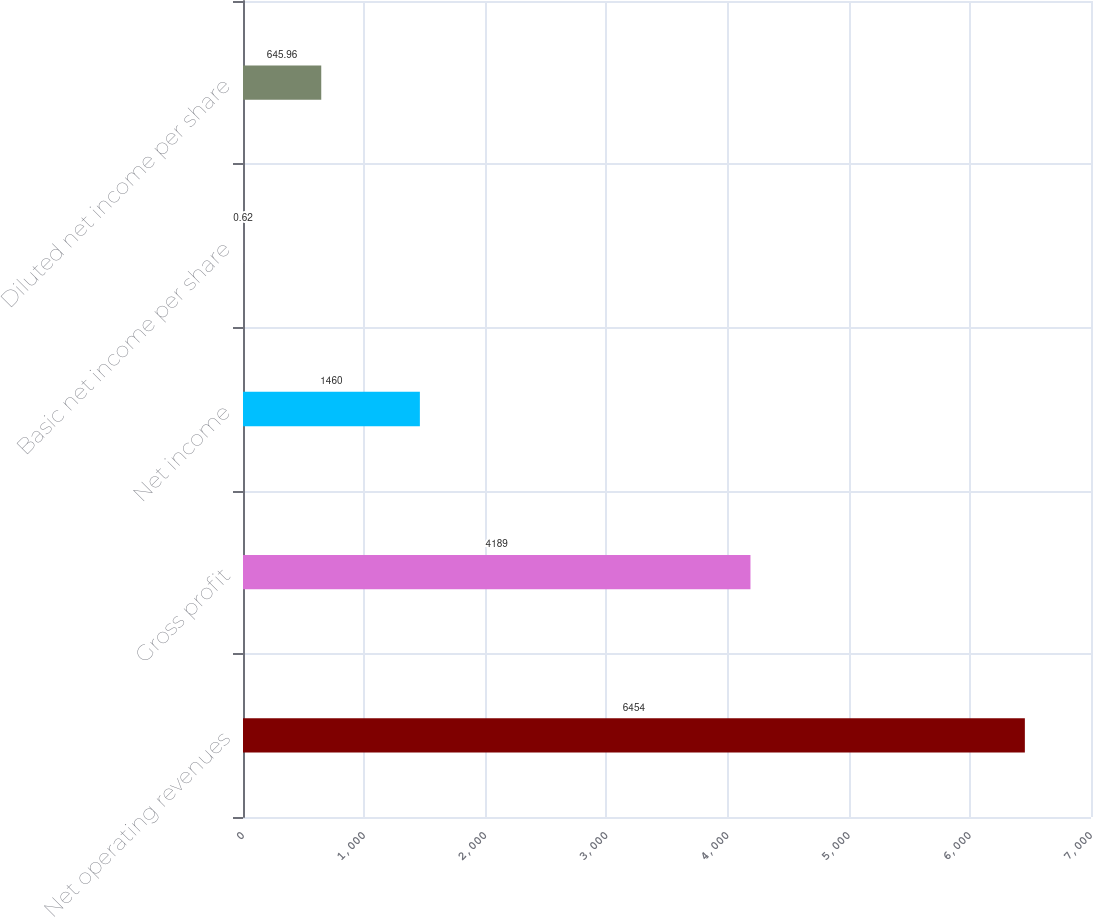Convert chart to OTSL. <chart><loc_0><loc_0><loc_500><loc_500><bar_chart><fcel>Net operating revenues<fcel>Gross profit<fcel>Net income<fcel>Basic net income per share<fcel>Diluted net income per share<nl><fcel>6454<fcel>4189<fcel>1460<fcel>0.62<fcel>645.96<nl></chart> 